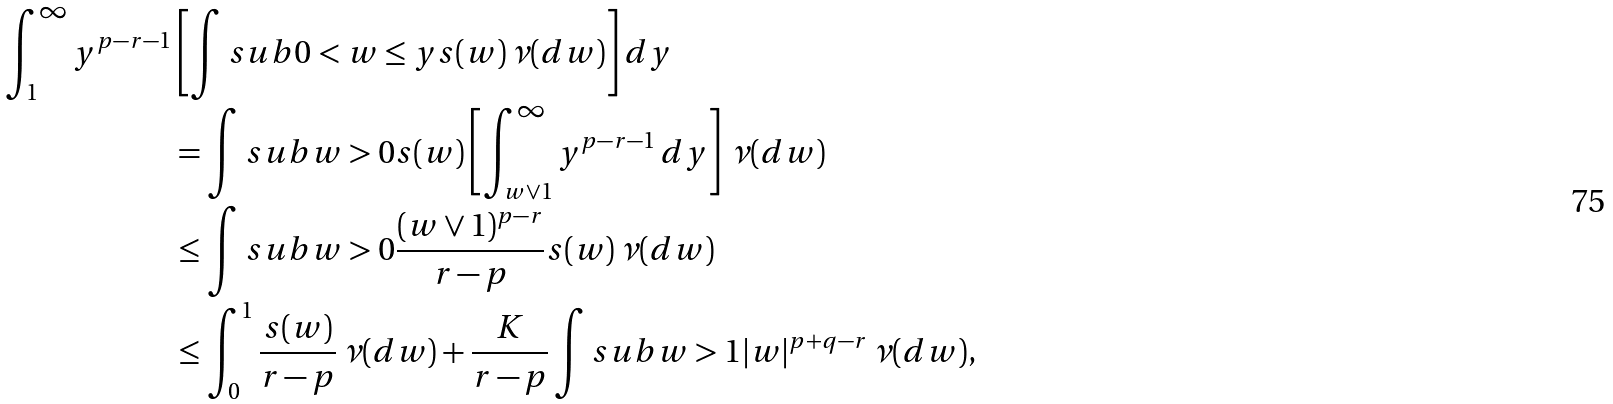Convert formula to latex. <formula><loc_0><loc_0><loc_500><loc_500>\int _ { 1 } ^ { \infty } y ^ { p - r - 1 } & \left [ \int s u b { 0 < w \leq y } s ( w ) \, \nu ( d w ) \right ] d y \\ & = \int s u b { w > 0 } s ( w ) \left [ \int _ { w \vee 1 } ^ { \infty } y ^ { p - r - 1 } \, d y \right ] \, \nu ( d w ) \\ & \leq \int s u b { w > 0 } \frac { ( w \vee 1 ) ^ { p - r } } { r - p } s ( w ) \, \nu ( d w ) \\ & \leq \int _ { 0 } ^ { 1 } \frac { s ( w ) } { r - p } \, \nu ( d w ) + \frac { K } { r - p } \int s u b { w > 1 } | w | ^ { p + q - r } \, \nu ( d w ) ,</formula> 